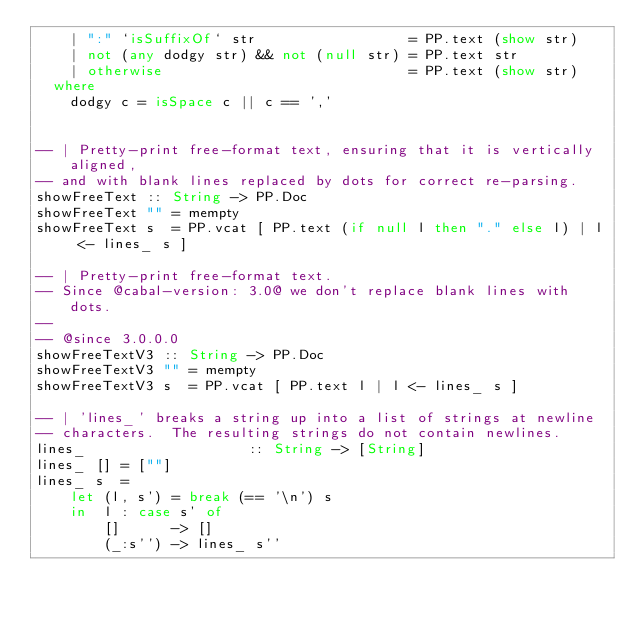Convert code to text. <code><loc_0><loc_0><loc_500><loc_500><_Haskell_>    | ":" `isSuffixOf` str                  = PP.text (show str)
    | not (any dodgy str) && not (null str) = PP.text str
    | otherwise                             = PP.text (show str)
  where
    dodgy c = isSpace c || c == ','


-- | Pretty-print free-format text, ensuring that it is vertically aligned,
-- and with blank lines replaced by dots for correct re-parsing.
showFreeText :: String -> PP.Doc
showFreeText "" = mempty
showFreeText s  = PP.vcat [ PP.text (if null l then "." else l) | l <- lines_ s ]

-- | Pretty-print free-format text.
-- Since @cabal-version: 3.0@ we don't replace blank lines with dots.
--
-- @since 3.0.0.0
showFreeTextV3 :: String -> PP.Doc
showFreeTextV3 "" = mempty
showFreeTextV3 s  = PP.vcat [ PP.text l | l <- lines_ s ]

-- | 'lines_' breaks a string up into a list of strings at newline
-- characters.  The resulting strings do not contain newlines.
lines_                   :: String -> [String]
lines_ [] = [""]
lines_ s  =
    let (l, s') = break (== '\n') s
    in  l : case s' of
        []      -> []
        (_:s'') -> lines_ s''
</code> 